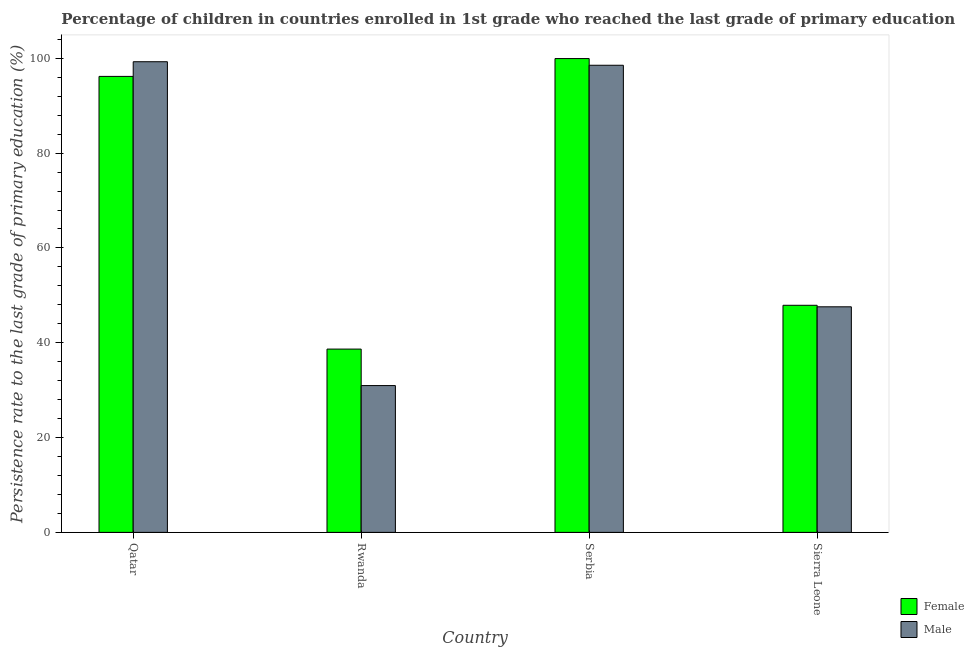How many different coloured bars are there?
Your answer should be compact. 2. Are the number of bars per tick equal to the number of legend labels?
Make the answer very short. Yes. How many bars are there on the 2nd tick from the left?
Make the answer very short. 2. What is the label of the 3rd group of bars from the left?
Provide a succinct answer. Serbia. In how many cases, is the number of bars for a given country not equal to the number of legend labels?
Keep it short and to the point. 0. What is the persistence rate of male students in Serbia?
Keep it short and to the point. 98.53. Across all countries, what is the maximum persistence rate of female students?
Provide a short and direct response. 99.95. Across all countries, what is the minimum persistence rate of female students?
Your response must be concise. 38.66. In which country was the persistence rate of male students maximum?
Your answer should be compact. Qatar. In which country was the persistence rate of male students minimum?
Keep it short and to the point. Rwanda. What is the total persistence rate of female students in the graph?
Make the answer very short. 282.7. What is the difference between the persistence rate of male students in Serbia and that in Sierra Leone?
Your answer should be compact. 50.95. What is the difference between the persistence rate of male students in Qatar and the persistence rate of female students in Rwanda?
Offer a terse response. 60.61. What is the average persistence rate of female students per country?
Give a very brief answer. 70.67. What is the difference between the persistence rate of female students and persistence rate of male students in Qatar?
Ensure brevity in your answer.  -3.09. In how many countries, is the persistence rate of male students greater than 40 %?
Provide a short and direct response. 3. What is the ratio of the persistence rate of male students in Serbia to that in Sierra Leone?
Provide a short and direct response. 2.07. Is the persistence rate of female students in Rwanda less than that in Serbia?
Your answer should be very brief. Yes. What is the difference between the highest and the second highest persistence rate of female students?
Make the answer very short. 3.76. What is the difference between the highest and the lowest persistence rate of female students?
Your answer should be compact. 61.28. Is the sum of the persistence rate of female students in Qatar and Rwanda greater than the maximum persistence rate of male students across all countries?
Provide a succinct answer. Yes. What does the 2nd bar from the right in Rwanda represents?
Your answer should be compact. Female. How many bars are there?
Offer a terse response. 8. Are all the bars in the graph horizontal?
Provide a short and direct response. No. How many countries are there in the graph?
Your response must be concise. 4. Does the graph contain any zero values?
Keep it short and to the point. No. How many legend labels are there?
Ensure brevity in your answer.  2. What is the title of the graph?
Offer a very short reply. Percentage of children in countries enrolled in 1st grade who reached the last grade of primary education. Does "Old" appear as one of the legend labels in the graph?
Offer a very short reply. No. What is the label or title of the X-axis?
Offer a very short reply. Country. What is the label or title of the Y-axis?
Make the answer very short. Persistence rate to the last grade of primary education (%). What is the Persistence rate to the last grade of primary education (%) of Female in Qatar?
Ensure brevity in your answer.  96.19. What is the Persistence rate to the last grade of primary education (%) of Male in Qatar?
Keep it short and to the point. 99.28. What is the Persistence rate to the last grade of primary education (%) in Female in Rwanda?
Ensure brevity in your answer.  38.66. What is the Persistence rate to the last grade of primary education (%) in Male in Rwanda?
Ensure brevity in your answer.  30.97. What is the Persistence rate to the last grade of primary education (%) in Female in Serbia?
Offer a very short reply. 99.95. What is the Persistence rate to the last grade of primary education (%) in Male in Serbia?
Provide a succinct answer. 98.53. What is the Persistence rate to the last grade of primary education (%) of Female in Sierra Leone?
Offer a very short reply. 47.9. What is the Persistence rate to the last grade of primary education (%) in Male in Sierra Leone?
Ensure brevity in your answer.  47.58. Across all countries, what is the maximum Persistence rate to the last grade of primary education (%) in Female?
Offer a very short reply. 99.95. Across all countries, what is the maximum Persistence rate to the last grade of primary education (%) in Male?
Provide a short and direct response. 99.28. Across all countries, what is the minimum Persistence rate to the last grade of primary education (%) of Female?
Give a very brief answer. 38.66. Across all countries, what is the minimum Persistence rate to the last grade of primary education (%) of Male?
Provide a short and direct response. 30.97. What is the total Persistence rate to the last grade of primary education (%) of Female in the graph?
Offer a terse response. 282.7. What is the total Persistence rate to the last grade of primary education (%) in Male in the graph?
Make the answer very short. 276.36. What is the difference between the Persistence rate to the last grade of primary education (%) in Female in Qatar and that in Rwanda?
Ensure brevity in your answer.  57.52. What is the difference between the Persistence rate to the last grade of primary education (%) in Male in Qatar and that in Rwanda?
Ensure brevity in your answer.  68.31. What is the difference between the Persistence rate to the last grade of primary education (%) in Female in Qatar and that in Serbia?
Provide a succinct answer. -3.76. What is the difference between the Persistence rate to the last grade of primary education (%) of Male in Qatar and that in Serbia?
Give a very brief answer. 0.75. What is the difference between the Persistence rate to the last grade of primary education (%) in Female in Qatar and that in Sierra Leone?
Provide a succinct answer. 48.28. What is the difference between the Persistence rate to the last grade of primary education (%) of Male in Qatar and that in Sierra Leone?
Your answer should be compact. 51.7. What is the difference between the Persistence rate to the last grade of primary education (%) of Female in Rwanda and that in Serbia?
Keep it short and to the point. -61.28. What is the difference between the Persistence rate to the last grade of primary education (%) in Male in Rwanda and that in Serbia?
Provide a short and direct response. -67.57. What is the difference between the Persistence rate to the last grade of primary education (%) in Female in Rwanda and that in Sierra Leone?
Offer a very short reply. -9.24. What is the difference between the Persistence rate to the last grade of primary education (%) of Male in Rwanda and that in Sierra Leone?
Offer a terse response. -16.61. What is the difference between the Persistence rate to the last grade of primary education (%) in Female in Serbia and that in Sierra Leone?
Make the answer very short. 52.04. What is the difference between the Persistence rate to the last grade of primary education (%) in Male in Serbia and that in Sierra Leone?
Provide a short and direct response. 50.95. What is the difference between the Persistence rate to the last grade of primary education (%) of Female in Qatar and the Persistence rate to the last grade of primary education (%) of Male in Rwanda?
Provide a succinct answer. 65.22. What is the difference between the Persistence rate to the last grade of primary education (%) of Female in Qatar and the Persistence rate to the last grade of primary education (%) of Male in Serbia?
Give a very brief answer. -2.35. What is the difference between the Persistence rate to the last grade of primary education (%) in Female in Qatar and the Persistence rate to the last grade of primary education (%) in Male in Sierra Leone?
Your response must be concise. 48.6. What is the difference between the Persistence rate to the last grade of primary education (%) of Female in Rwanda and the Persistence rate to the last grade of primary education (%) of Male in Serbia?
Make the answer very short. -59.87. What is the difference between the Persistence rate to the last grade of primary education (%) in Female in Rwanda and the Persistence rate to the last grade of primary education (%) in Male in Sierra Leone?
Make the answer very short. -8.92. What is the difference between the Persistence rate to the last grade of primary education (%) of Female in Serbia and the Persistence rate to the last grade of primary education (%) of Male in Sierra Leone?
Make the answer very short. 52.36. What is the average Persistence rate to the last grade of primary education (%) of Female per country?
Your answer should be compact. 70.67. What is the average Persistence rate to the last grade of primary education (%) in Male per country?
Give a very brief answer. 69.09. What is the difference between the Persistence rate to the last grade of primary education (%) of Female and Persistence rate to the last grade of primary education (%) of Male in Qatar?
Make the answer very short. -3.09. What is the difference between the Persistence rate to the last grade of primary education (%) of Female and Persistence rate to the last grade of primary education (%) of Male in Rwanda?
Provide a succinct answer. 7.7. What is the difference between the Persistence rate to the last grade of primary education (%) in Female and Persistence rate to the last grade of primary education (%) in Male in Serbia?
Your answer should be compact. 1.41. What is the difference between the Persistence rate to the last grade of primary education (%) of Female and Persistence rate to the last grade of primary education (%) of Male in Sierra Leone?
Keep it short and to the point. 0.32. What is the ratio of the Persistence rate to the last grade of primary education (%) of Female in Qatar to that in Rwanda?
Your answer should be compact. 2.49. What is the ratio of the Persistence rate to the last grade of primary education (%) in Male in Qatar to that in Rwanda?
Your response must be concise. 3.21. What is the ratio of the Persistence rate to the last grade of primary education (%) of Female in Qatar to that in Serbia?
Make the answer very short. 0.96. What is the ratio of the Persistence rate to the last grade of primary education (%) in Male in Qatar to that in Serbia?
Your response must be concise. 1.01. What is the ratio of the Persistence rate to the last grade of primary education (%) of Female in Qatar to that in Sierra Leone?
Your answer should be compact. 2.01. What is the ratio of the Persistence rate to the last grade of primary education (%) of Male in Qatar to that in Sierra Leone?
Offer a very short reply. 2.09. What is the ratio of the Persistence rate to the last grade of primary education (%) of Female in Rwanda to that in Serbia?
Your answer should be very brief. 0.39. What is the ratio of the Persistence rate to the last grade of primary education (%) in Male in Rwanda to that in Serbia?
Make the answer very short. 0.31. What is the ratio of the Persistence rate to the last grade of primary education (%) in Female in Rwanda to that in Sierra Leone?
Your answer should be very brief. 0.81. What is the ratio of the Persistence rate to the last grade of primary education (%) in Male in Rwanda to that in Sierra Leone?
Your response must be concise. 0.65. What is the ratio of the Persistence rate to the last grade of primary education (%) of Female in Serbia to that in Sierra Leone?
Make the answer very short. 2.09. What is the ratio of the Persistence rate to the last grade of primary education (%) of Male in Serbia to that in Sierra Leone?
Offer a very short reply. 2.07. What is the difference between the highest and the second highest Persistence rate to the last grade of primary education (%) of Female?
Provide a short and direct response. 3.76. What is the difference between the highest and the second highest Persistence rate to the last grade of primary education (%) in Male?
Offer a terse response. 0.75. What is the difference between the highest and the lowest Persistence rate to the last grade of primary education (%) of Female?
Offer a terse response. 61.28. What is the difference between the highest and the lowest Persistence rate to the last grade of primary education (%) of Male?
Offer a very short reply. 68.31. 